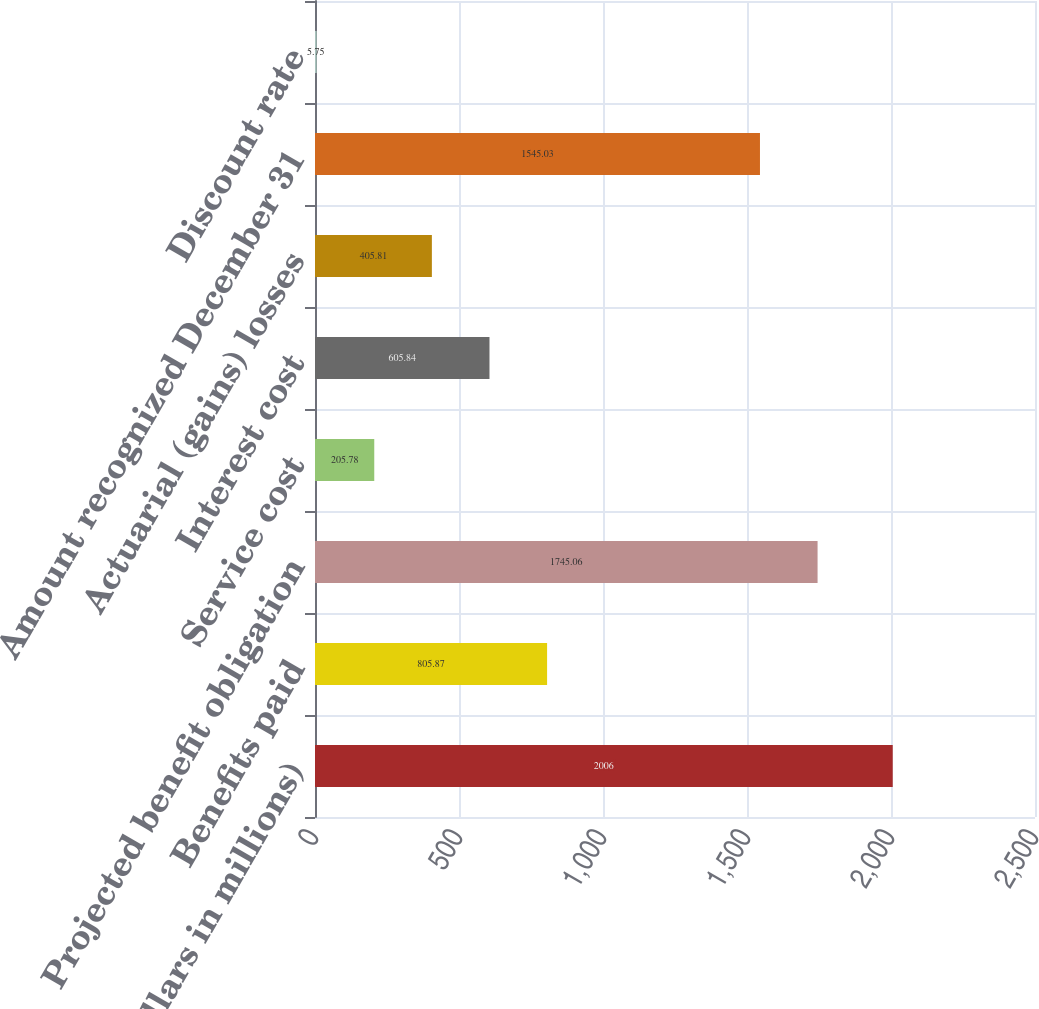<chart> <loc_0><loc_0><loc_500><loc_500><bar_chart><fcel>(Dollars in millions)<fcel>Benefits paid<fcel>Projected benefit obligation<fcel>Service cost<fcel>Interest cost<fcel>Actuarial (gains) losses<fcel>Amount recognized December 31<fcel>Discount rate<nl><fcel>2006<fcel>805.87<fcel>1745.06<fcel>205.78<fcel>605.84<fcel>405.81<fcel>1545.03<fcel>5.75<nl></chart> 